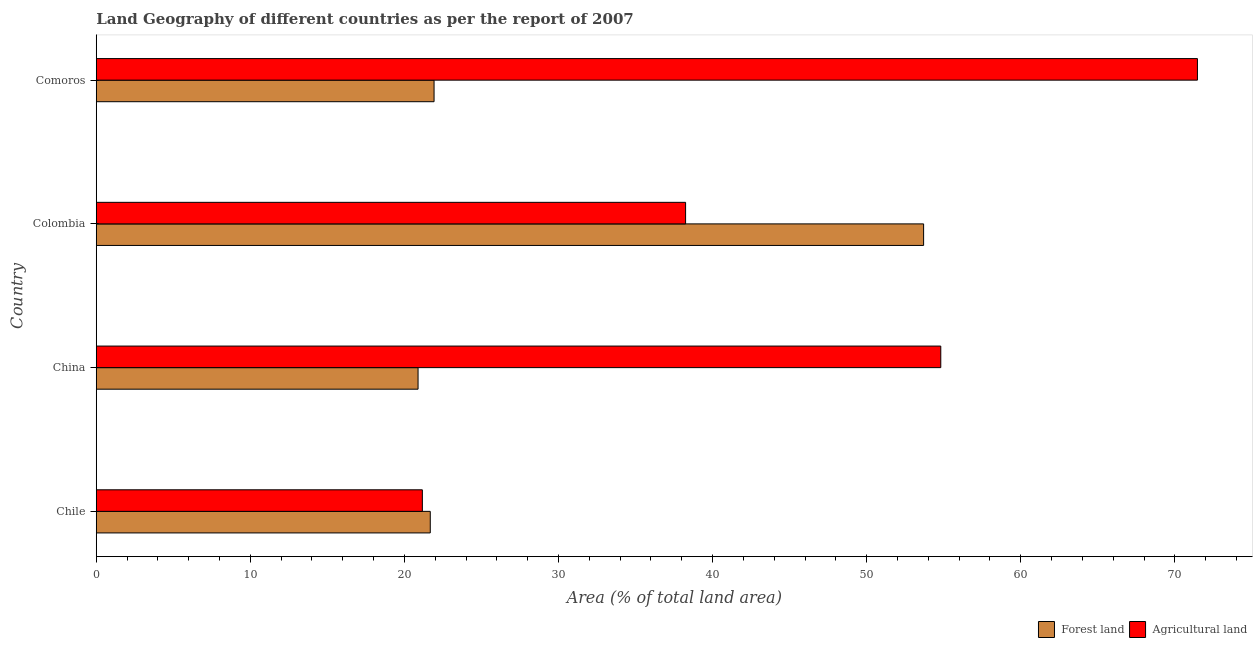Are the number of bars per tick equal to the number of legend labels?
Provide a succinct answer. Yes. Are the number of bars on each tick of the Y-axis equal?
Make the answer very short. Yes. How many bars are there on the 1st tick from the bottom?
Offer a very short reply. 2. What is the label of the 1st group of bars from the top?
Your answer should be compact. Comoros. In how many cases, is the number of bars for a given country not equal to the number of legend labels?
Offer a very short reply. 0. What is the percentage of land area under agriculture in China?
Give a very brief answer. 54.81. Across all countries, what is the maximum percentage of land area under agriculture?
Provide a short and direct response. 71.47. Across all countries, what is the minimum percentage of land area under agriculture?
Your answer should be very brief. 21.16. What is the total percentage of land area under forests in the graph?
Provide a succinct answer. 118.18. What is the difference between the percentage of land area under forests in China and that in Comoros?
Make the answer very short. -1.04. What is the difference between the percentage of land area under forests in Colombia and the percentage of land area under agriculture in Comoros?
Make the answer very short. -17.77. What is the average percentage of land area under agriculture per country?
Give a very brief answer. 46.42. What is the difference between the percentage of land area under forests and percentage of land area under agriculture in Comoros?
Your response must be concise. -49.54. What is the ratio of the percentage of land area under agriculture in Colombia to that in Comoros?
Provide a succinct answer. 0.54. Is the percentage of land area under agriculture in Chile less than that in China?
Ensure brevity in your answer.  Yes. What is the difference between the highest and the second highest percentage of land area under forests?
Make the answer very short. 31.77. What is the difference between the highest and the lowest percentage of land area under agriculture?
Provide a short and direct response. 50.3. What does the 1st bar from the top in Chile represents?
Your answer should be compact. Agricultural land. What does the 1st bar from the bottom in Colombia represents?
Give a very brief answer. Forest land. How many bars are there?
Offer a very short reply. 8. Are all the bars in the graph horizontal?
Offer a terse response. Yes. Are the values on the major ticks of X-axis written in scientific E-notation?
Provide a short and direct response. No. Does the graph contain any zero values?
Make the answer very short. No. Does the graph contain grids?
Offer a very short reply. No. Where does the legend appear in the graph?
Provide a short and direct response. Bottom right. How are the legend labels stacked?
Offer a very short reply. Horizontal. What is the title of the graph?
Give a very brief answer. Land Geography of different countries as per the report of 2007. Does "Agricultural land" appear as one of the legend labels in the graph?
Your answer should be very brief. Yes. What is the label or title of the X-axis?
Provide a short and direct response. Area (% of total land area). What is the Area (% of total land area) in Forest land in Chile?
Offer a very short reply. 21.68. What is the Area (% of total land area) of Agricultural land in Chile?
Give a very brief answer. 21.16. What is the Area (% of total land area) in Forest land in China?
Your answer should be very brief. 20.88. What is the Area (% of total land area) of Agricultural land in China?
Keep it short and to the point. 54.81. What is the Area (% of total land area) of Forest land in Colombia?
Ensure brevity in your answer.  53.7. What is the Area (% of total land area) in Agricultural land in Colombia?
Make the answer very short. 38.25. What is the Area (% of total land area) in Forest land in Comoros?
Give a very brief answer. 21.92. What is the Area (% of total land area) in Agricultural land in Comoros?
Your answer should be very brief. 71.47. Across all countries, what is the maximum Area (% of total land area) of Forest land?
Your answer should be compact. 53.7. Across all countries, what is the maximum Area (% of total land area) in Agricultural land?
Make the answer very short. 71.47. Across all countries, what is the minimum Area (% of total land area) of Forest land?
Your answer should be very brief. 20.88. Across all countries, what is the minimum Area (% of total land area) in Agricultural land?
Your answer should be compact. 21.16. What is the total Area (% of total land area) in Forest land in the graph?
Your response must be concise. 118.18. What is the total Area (% of total land area) in Agricultural land in the graph?
Keep it short and to the point. 185.69. What is the difference between the Area (% of total land area) of Forest land in Chile and that in China?
Your answer should be very brief. 0.79. What is the difference between the Area (% of total land area) of Agricultural land in Chile and that in China?
Give a very brief answer. -33.65. What is the difference between the Area (% of total land area) of Forest land in Chile and that in Colombia?
Keep it short and to the point. -32.02. What is the difference between the Area (% of total land area) of Agricultural land in Chile and that in Colombia?
Offer a very short reply. -17.08. What is the difference between the Area (% of total land area) in Forest land in Chile and that in Comoros?
Provide a short and direct response. -0.25. What is the difference between the Area (% of total land area) of Agricultural land in Chile and that in Comoros?
Make the answer very short. -50.3. What is the difference between the Area (% of total land area) in Forest land in China and that in Colombia?
Your answer should be very brief. -32.81. What is the difference between the Area (% of total land area) in Agricultural land in China and that in Colombia?
Keep it short and to the point. 16.56. What is the difference between the Area (% of total land area) in Forest land in China and that in Comoros?
Keep it short and to the point. -1.04. What is the difference between the Area (% of total land area) in Agricultural land in China and that in Comoros?
Offer a terse response. -16.66. What is the difference between the Area (% of total land area) in Forest land in Colombia and that in Comoros?
Keep it short and to the point. 31.77. What is the difference between the Area (% of total land area) of Agricultural land in Colombia and that in Comoros?
Provide a short and direct response. -33.22. What is the difference between the Area (% of total land area) of Forest land in Chile and the Area (% of total land area) of Agricultural land in China?
Provide a short and direct response. -33.13. What is the difference between the Area (% of total land area) of Forest land in Chile and the Area (% of total land area) of Agricultural land in Colombia?
Provide a short and direct response. -16.57. What is the difference between the Area (% of total land area) of Forest land in Chile and the Area (% of total land area) of Agricultural land in Comoros?
Ensure brevity in your answer.  -49.79. What is the difference between the Area (% of total land area) in Forest land in China and the Area (% of total land area) in Agricultural land in Colombia?
Provide a succinct answer. -17.36. What is the difference between the Area (% of total land area) of Forest land in China and the Area (% of total land area) of Agricultural land in Comoros?
Provide a succinct answer. -50.58. What is the difference between the Area (% of total land area) of Forest land in Colombia and the Area (% of total land area) of Agricultural land in Comoros?
Keep it short and to the point. -17.77. What is the average Area (% of total land area) in Forest land per country?
Your answer should be very brief. 29.55. What is the average Area (% of total land area) of Agricultural land per country?
Your answer should be very brief. 46.42. What is the difference between the Area (% of total land area) in Forest land and Area (% of total land area) in Agricultural land in Chile?
Your answer should be very brief. 0.51. What is the difference between the Area (% of total land area) of Forest land and Area (% of total land area) of Agricultural land in China?
Ensure brevity in your answer.  -33.93. What is the difference between the Area (% of total land area) in Forest land and Area (% of total land area) in Agricultural land in Colombia?
Give a very brief answer. 15.45. What is the difference between the Area (% of total land area) of Forest land and Area (% of total land area) of Agricultural land in Comoros?
Keep it short and to the point. -49.54. What is the ratio of the Area (% of total land area) of Forest land in Chile to that in China?
Make the answer very short. 1.04. What is the ratio of the Area (% of total land area) in Agricultural land in Chile to that in China?
Make the answer very short. 0.39. What is the ratio of the Area (% of total land area) of Forest land in Chile to that in Colombia?
Your answer should be compact. 0.4. What is the ratio of the Area (% of total land area) of Agricultural land in Chile to that in Colombia?
Give a very brief answer. 0.55. What is the ratio of the Area (% of total land area) in Agricultural land in Chile to that in Comoros?
Your response must be concise. 0.3. What is the ratio of the Area (% of total land area) of Forest land in China to that in Colombia?
Your answer should be compact. 0.39. What is the ratio of the Area (% of total land area) of Agricultural land in China to that in Colombia?
Your response must be concise. 1.43. What is the ratio of the Area (% of total land area) of Forest land in China to that in Comoros?
Make the answer very short. 0.95. What is the ratio of the Area (% of total land area) in Agricultural land in China to that in Comoros?
Provide a succinct answer. 0.77. What is the ratio of the Area (% of total land area) of Forest land in Colombia to that in Comoros?
Provide a succinct answer. 2.45. What is the ratio of the Area (% of total land area) of Agricultural land in Colombia to that in Comoros?
Offer a very short reply. 0.54. What is the difference between the highest and the second highest Area (% of total land area) of Forest land?
Keep it short and to the point. 31.77. What is the difference between the highest and the second highest Area (% of total land area) in Agricultural land?
Keep it short and to the point. 16.66. What is the difference between the highest and the lowest Area (% of total land area) in Forest land?
Make the answer very short. 32.81. What is the difference between the highest and the lowest Area (% of total land area) of Agricultural land?
Provide a succinct answer. 50.3. 